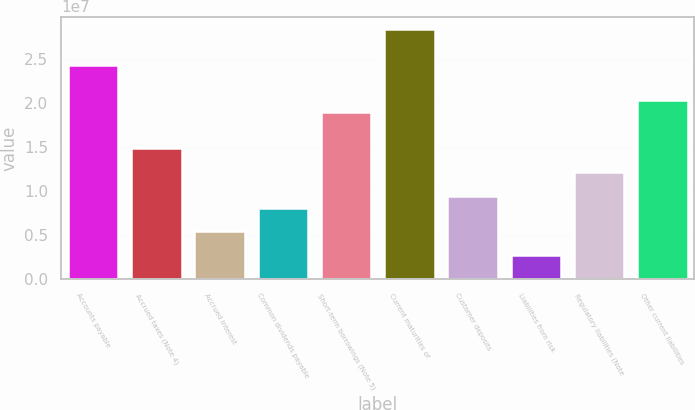Convert chart to OTSL. <chart><loc_0><loc_0><loc_500><loc_500><bar_chart><fcel>Accounts payable<fcel>Accrued taxes (Note 4)<fcel>Accrued interest<fcel>Common dividends payable<fcel>Short-term borrowings (Note 5)<fcel>Current maturities of<fcel>Customer deposits<fcel>Liabilities from risk<fcel>Regulatory liabilities (Note<fcel>Other current liabilities<nl><fcel>2.43122e+07<fcel>1.48591e+07<fcel>5.40606e+06<fcel>8.10693e+06<fcel>1.89104e+07<fcel>2.83635e+07<fcel>9.45737e+06<fcel>2.70518e+06<fcel>1.21582e+07<fcel>2.02609e+07<nl></chart> 